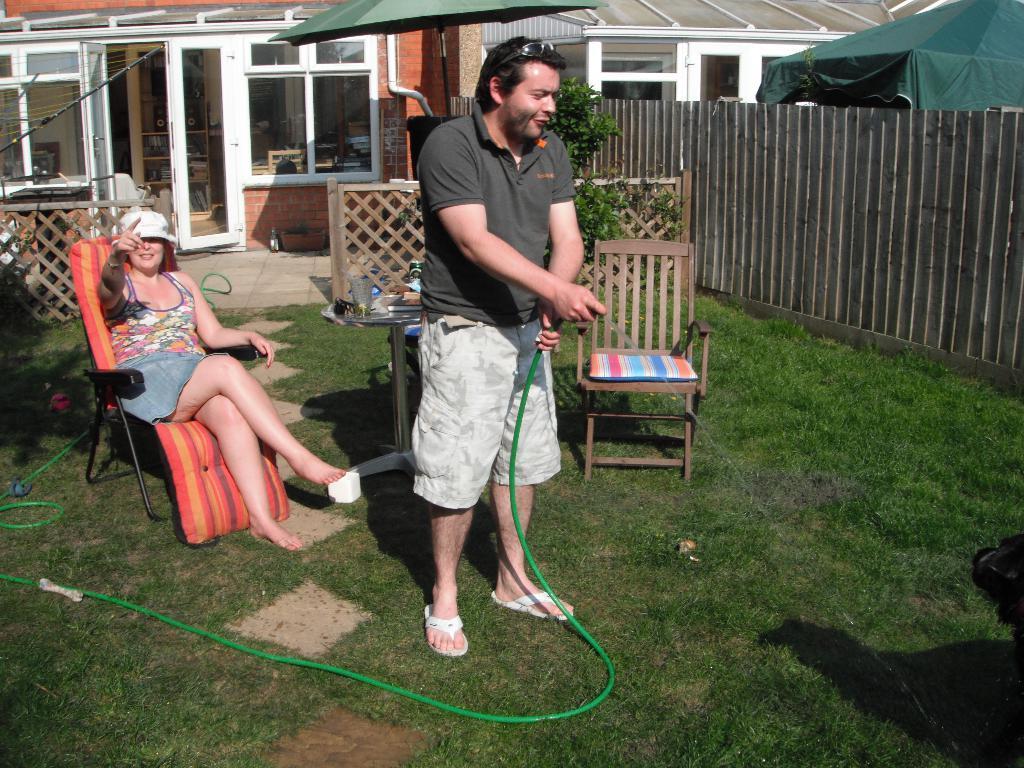Can you describe this image briefly? In this picture we can see a woman sitting on a chair and a man standing on the ground and holding a pipe with his hands and in the background we can see a table, fence, tree, buildings with windows, tent. 